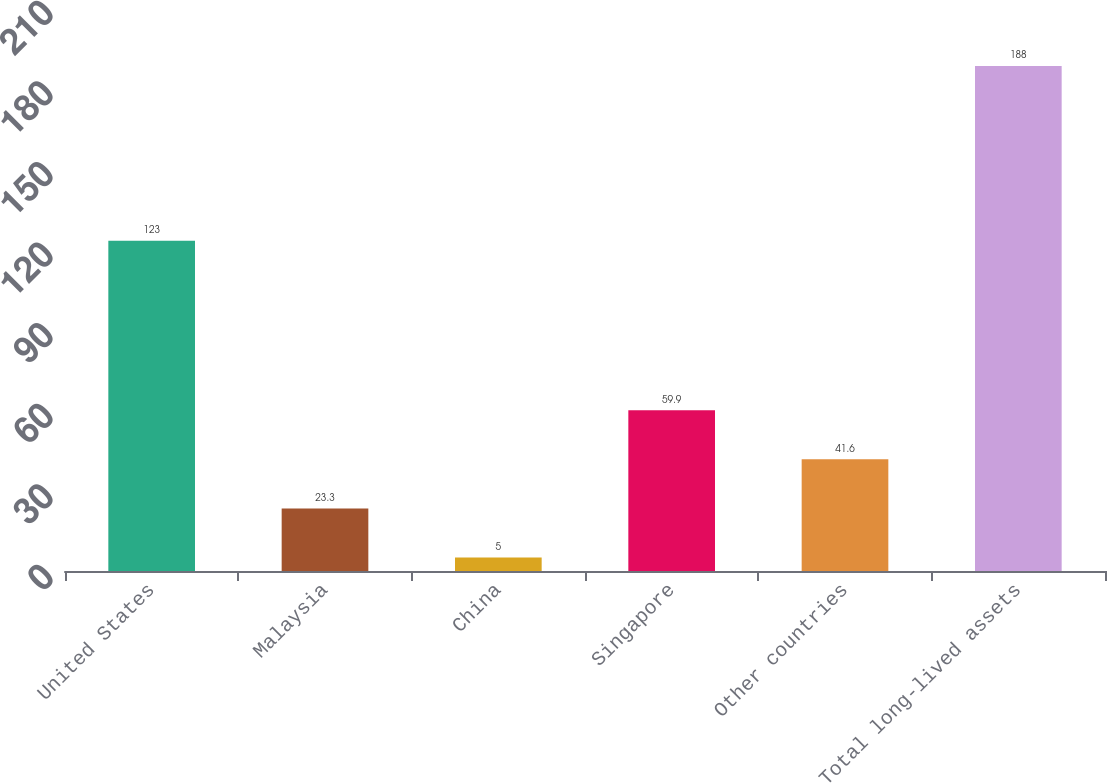<chart> <loc_0><loc_0><loc_500><loc_500><bar_chart><fcel>United States<fcel>Malaysia<fcel>China<fcel>Singapore<fcel>Other countries<fcel>Total long-lived assets<nl><fcel>123<fcel>23.3<fcel>5<fcel>59.9<fcel>41.6<fcel>188<nl></chart> 